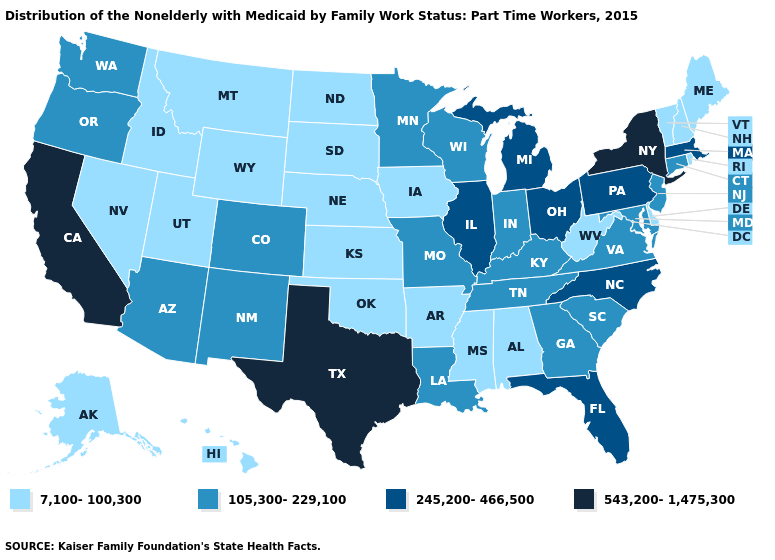Name the states that have a value in the range 543,200-1,475,300?
Keep it brief. California, New York, Texas. Name the states that have a value in the range 7,100-100,300?
Answer briefly. Alabama, Alaska, Arkansas, Delaware, Hawaii, Idaho, Iowa, Kansas, Maine, Mississippi, Montana, Nebraska, Nevada, New Hampshire, North Dakota, Oklahoma, Rhode Island, South Dakota, Utah, Vermont, West Virginia, Wyoming. Name the states that have a value in the range 7,100-100,300?
Concise answer only. Alabama, Alaska, Arkansas, Delaware, Hawaii, Idaho, Iowa, Kansas, Maine, Mississippi, Montana, Nebraska, Nevada, New Hampshire, North Dakota, Oklahoma, Rhode Island, South Dakota, Utah, Vermont, West Virginia, Wyoming. Which states have the lowest value in the MidWest?
Short answer required. Iowa, Kansas, Nebraska, North Dakota, South Dakota. Among the states that border New Mexico , which have the highest value?
Give a very brief answer. Texas. What is the lowest value in states that border Virginia?
Be succinct. 7,100-100,300. Does Texas have the highest value in the USA?
Quick response, please. Yes. Among the states that border Ohio , does West Virginia have the lowest value?
Be succinct. Yes. Name the states that have a value in the range 245,200-466,500?
Be succinct. Florida, Illinois, Massachusetts, Michigan, North Carolina, Ohio, Pennsylvania. Does Wyoming have the lowest value in the West?
Be succinct. Yes. Name the states that have a value in the range 245,200-466,500?
Be succinct. Florida, Illinois, Massachusetts, Michigan, North Carolina, Ohio, Pennsylvania. Does Rhode Island have the highest value in the USA?
Short answer required. No. Which states hav the highest value in the Northeast?
Give a very brief answer. New York. Does Illinois have a lower value than Wisconsin?
Be succinct. No. Does Kansas have the highest value in the USA?
Concise answer only. No. 